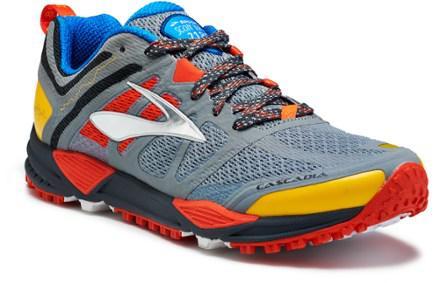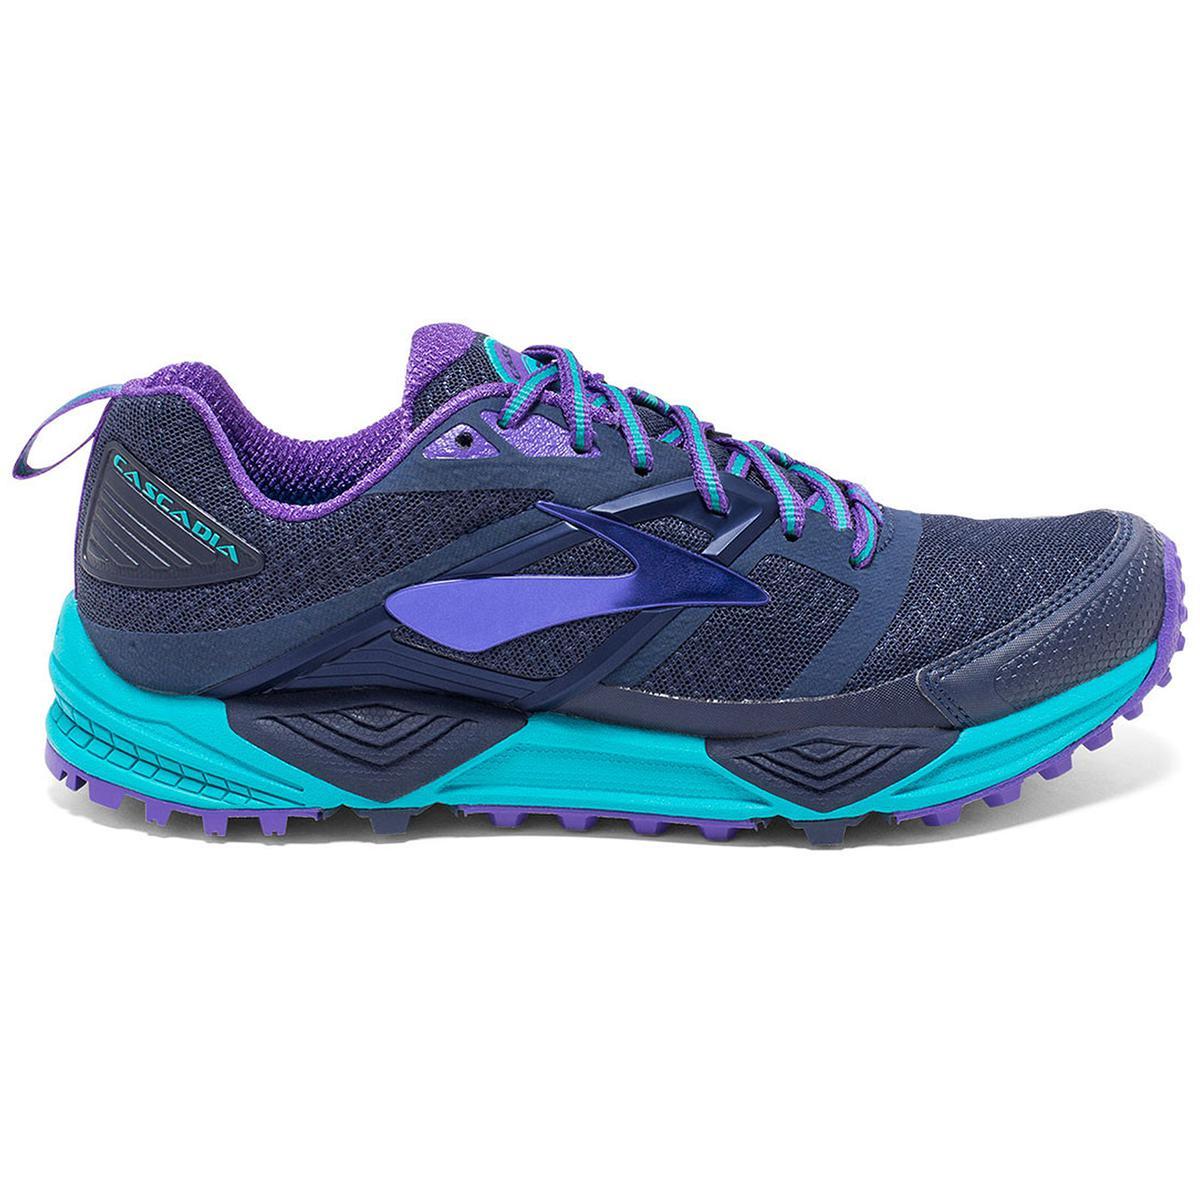The first image is the image on the left, the second image is the image on the right. Considering the images on both sides, is "The shoe on the left has laces tied into a bow while the shoe on the right has laces that tighten without tying." valid? Answer yes or no. No. The first image is the image on the left, the second image is the image on the right. Given the left and right images, does the statement "One of the shoes has the laces tied in a bow." hold true? Answer yes or no. No. 